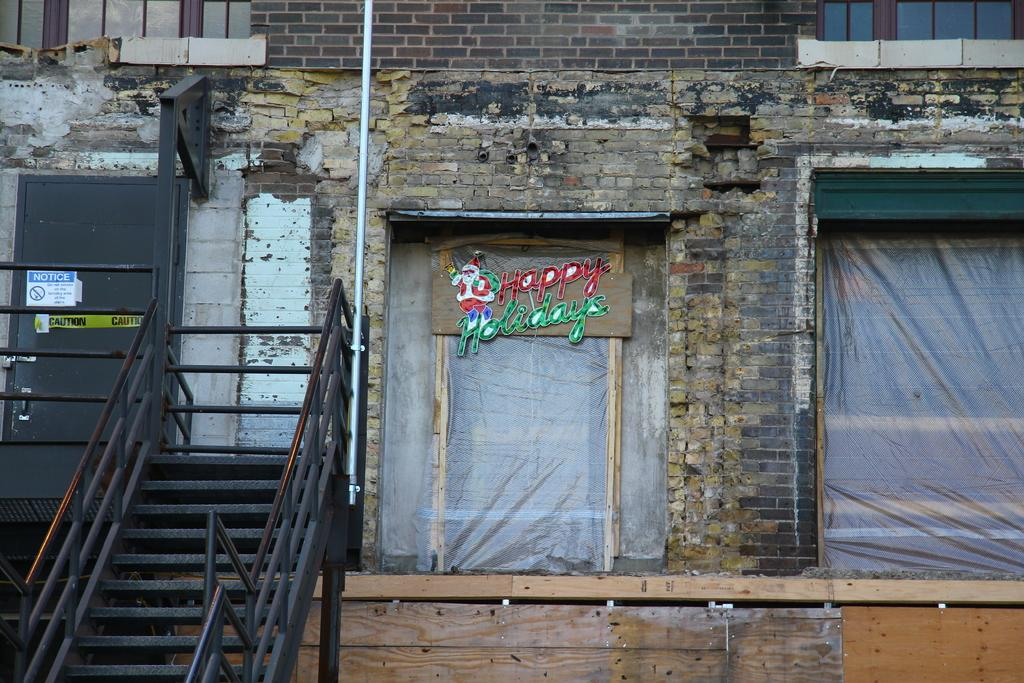What structure is the main subject of the image? There is a building in the image. What architectural feature is located in front of the building? There are stairs in front of the building. What can be seen beside the stairs? There are windows beside the stairs. Is there any text visible on the windows? Yes, there is text on one of the windows. Can you tell me how many wrens are perched on the windowsill in the image? There are no wrens present in the image. What type of coat is the person wearing while standing on the stairs in the image? There is no person visible in the image, so we cannot determine what type of coat they might be wearing. 